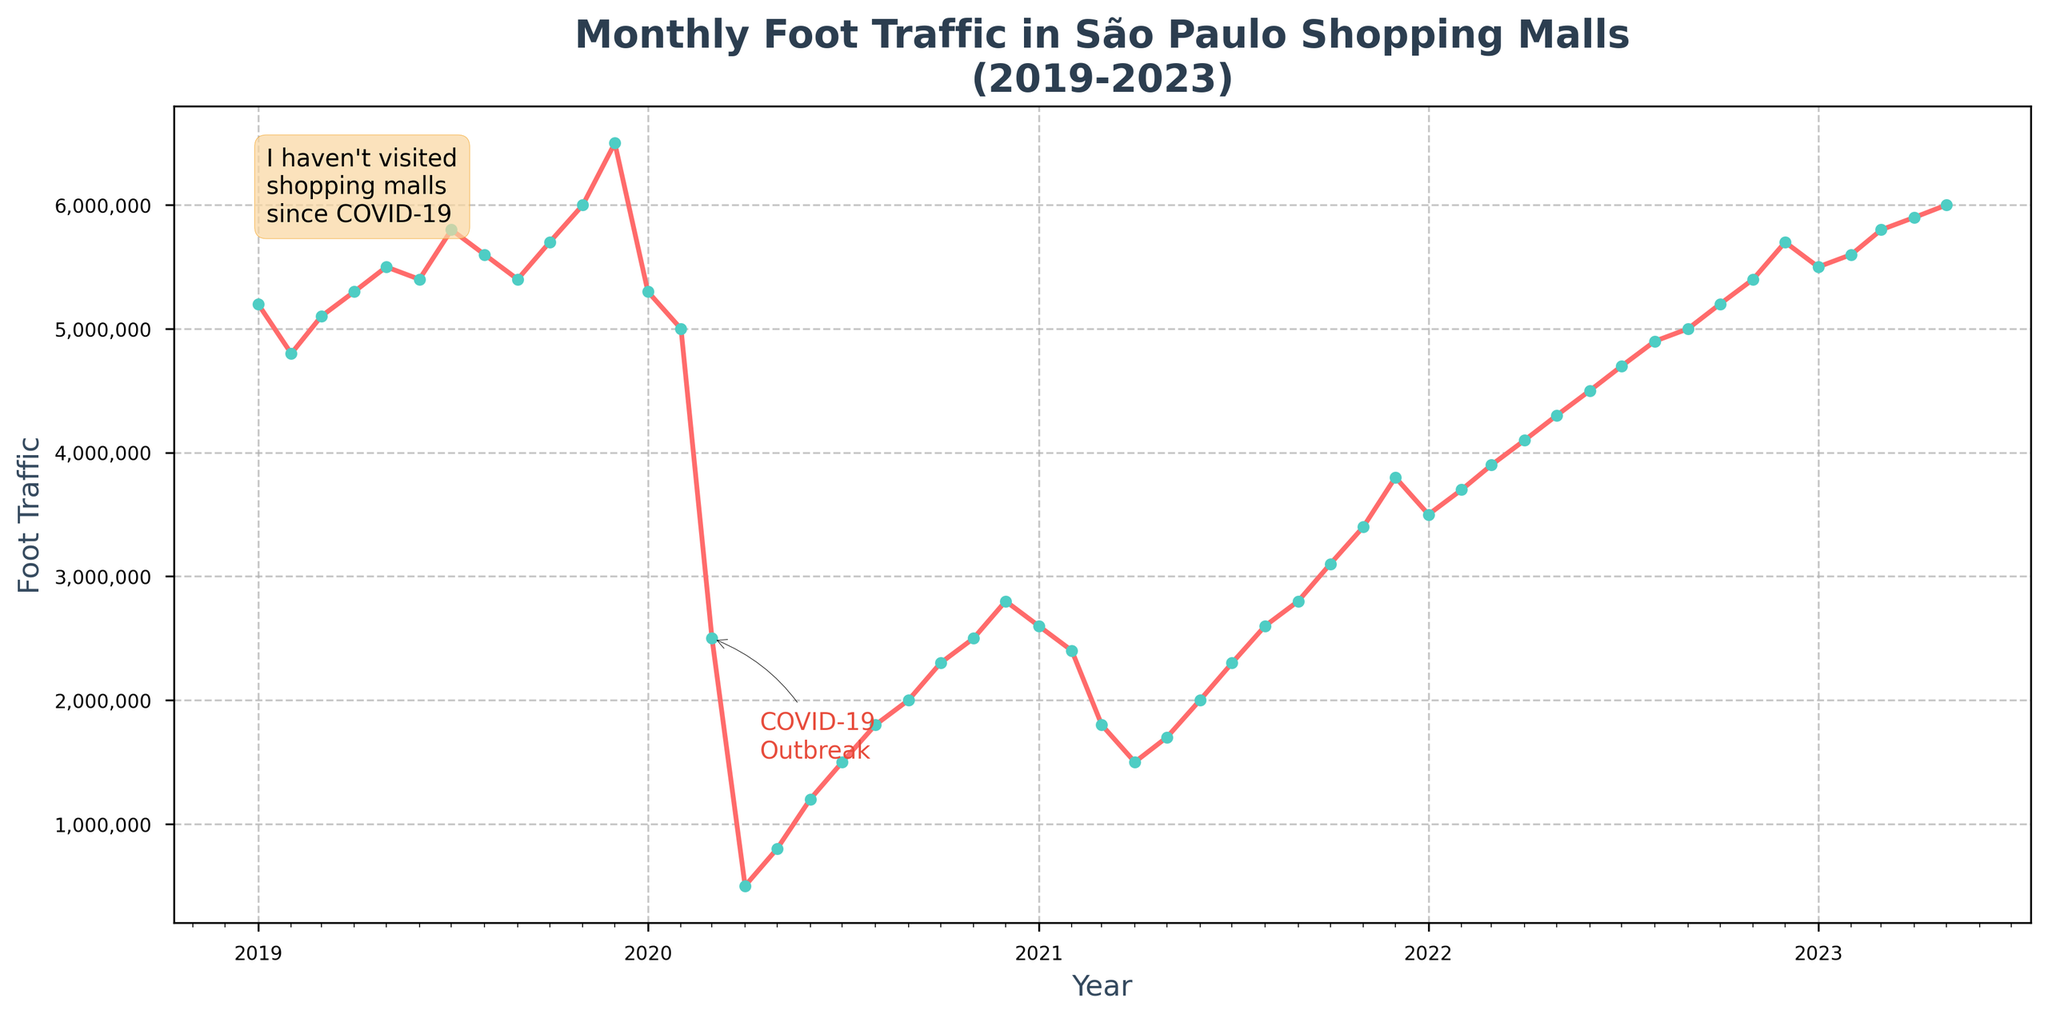When did the foot traffic in São Paulo shopping malls drop significantly due to COVID-19? The significant drop occurred in March 2020. The foot traffic decreased from around 5 million in February 2020 to 2.5 million in March 2020. This drastic change indicates the impact of the COVID-19 outbreak.
Answer: March 2020 How did the foot traffic in December 2022 compare with December 2019? In December 2019, the foot traffic was 6.5 million, while in December 2022, it was only 5.7 million. This shows that there was a decrease in foot traffic.
Answer: Decreased What was the average foot traffic in the year 2021? To calculate the average, sum the foot traffic values for each month in 2021: \(2.6 + 2.4 + 1.8 + 1.5 + 1.7 + 2.0 + 2.3 + 2.6 + 2.8 + 3.1 + 3.4 + 3.8 = 31.0\) million, then divide by 12.
Answer: 2.583 million Did the foot traffic in May 2023 exceed 5.5 million? Look at the data point for May 2023. The foot traffic in May 2023 is 6 million, which exceeds 5.5 million.
Answer: Yes Which year showed a general trend of recovery in foot traffic after the initial COVID-19 impact in 2020? Observing the data and the plot, the year 2021 shows a general trend of recovery from the initial COVID-19 impact with steady increases each month.
Answer: 2021 Compare the foot traffic in April 2020 to April 2023. In April 2020, the foot traffic was 0.5 million, while in April 2023, it was 5.9 million. There is a significant increase when comparing these two months.
Answer: Increased How did foot traffic change from July 2019 to July 2020? In July 2019, foot traffic was 5.8 million, but in July 2020, it dropped to 1.5 million, reflecting a significant decrease due to COVID-19.
Answer: Decreased What is the median foot traffic value for the year 2022? For 2022, arrange the foot traffic values in ascending order and find the median. The values are \(3.5, 3.7, 3.9, 4.1, 4.3, 4.5, 4.7, 4.9, 5.0, 5.2, 5.4, 5.7\). The median is the average of the 6th and 7th values: \((4.5 + 4.7) / 2 = 4.6\).
Answer: 4.6 million What visual cue indicates when the COVID-19 outbreak affected the foot traffic in malls? The plot includes an annotation stating "COVID-19 Outbreak" marked with an arrow pointing to March 2020, indicating the start of the significant drop.
Answer: Annotation in March 2020 